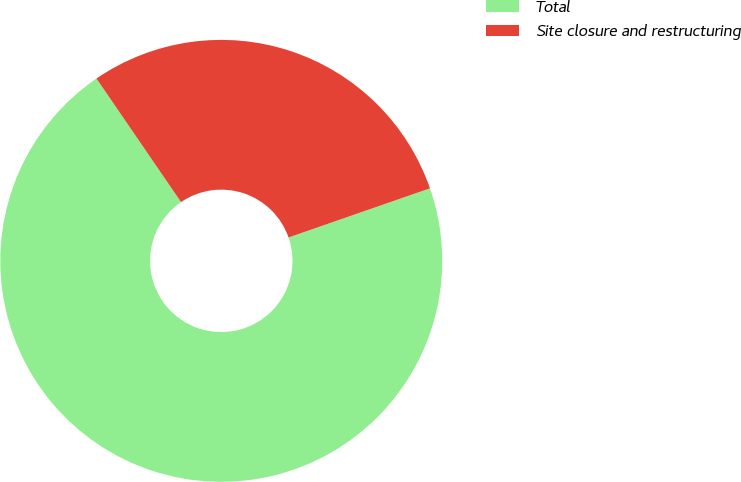<chart> <loc_0><loc_0><loc_500><loc_500><pie_chart><fcel>Total<fcel>Site closure and restructuring<nl><fcel>70.77%<fcel>29.23%<nl></chart> 